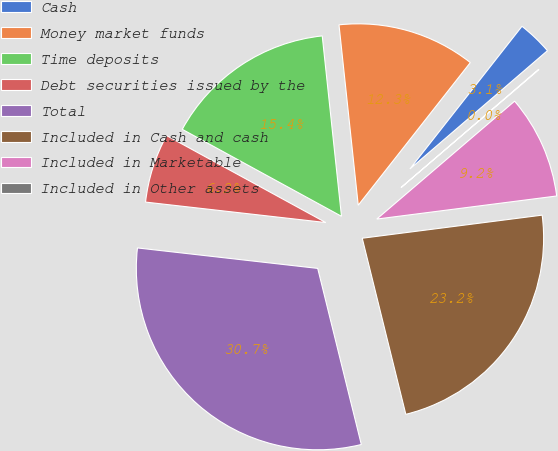Convert chart to OTSL. <chart><loc_0><loc_0><loc_500><loc_500><pie_chart><fcel>Cash<fcel>Money market funds<fcel>Time deposits<fcel>Debt securities issued by the<fcel>Total<fcel>Included in Cash and cash<fcel>Included in Marketable<fcel>Included in Other assets<nl><fcel>3.1%<fcel>12.29%<fcel>15.35%<fcel>6.16%<fcel>30.66%<fcel>23.17%<fcel>9.23%<fcel>0.04%<nl></chart> 